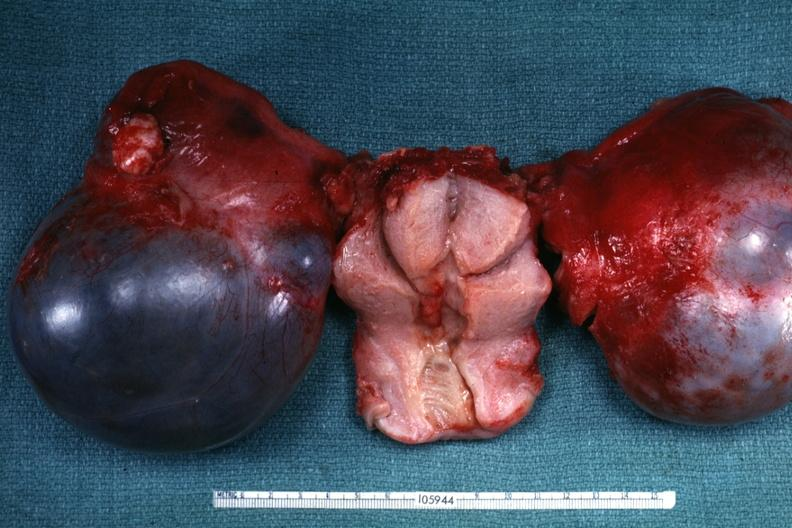s female reproductive present?
Answer the question using a single word or phrase. Yes 